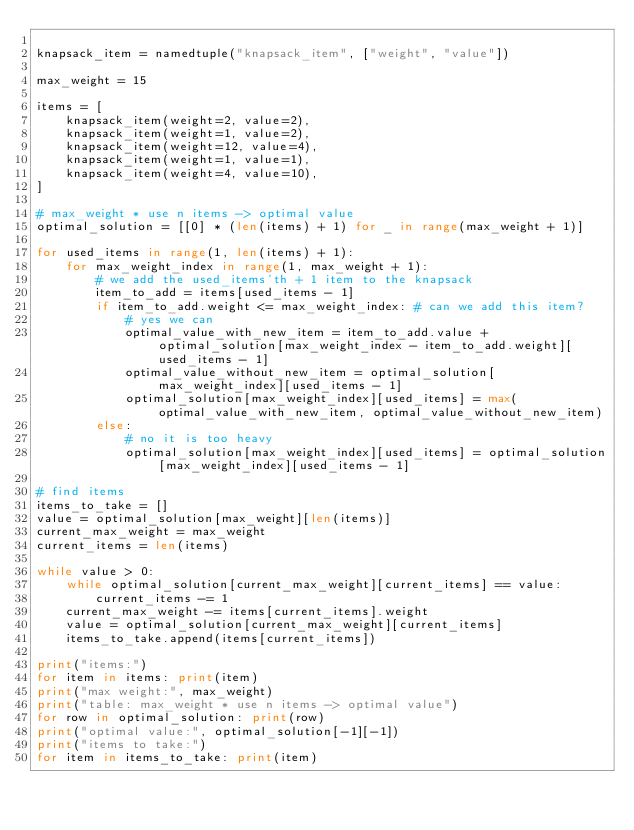Convert code to text. <code><loc_0><loc_0><loc_500><loc_500><_Python_>
knapsack_item = namedtuple("knapsack_item", ["weight", "value"])

max_weight = 15

items = [
    knapsack_item(weight=2, value=2),
    knapsack_item(weight=1, value=2),
    knapsack_item(weight=12, value=4),
    knapsack_item(weight=1, value=1),
    knapsack_item(weight=4, value=10),
]

# max_weight * use n items -> optimal value
optimal_solution = [[0] * (len(items) + 1) for _ in range(max_weight + 1)]

for used_items in range(1, len(items) + 1):
    for max_weight_index in range(1, max_weight + 1):
        # we add the used_items'th + 1 item to the knapsack
        item_to_add = items[used_items - 1]
        if item_to_add.weight <= max_weight_index: # can we add this item?
            # yes we can
            optimal_value_with_new_item = item_to_add.value + optimal_solution[max_weight_index - item_to_add.weight][used_items - 1]
            optimal_value_without_new_item = optimal_solution[max_weight_index][used_items - 1]
            optimal_solution[max_weight_index][used_items] = max(optimal_value_with_new_item, optimal_value_without_new_item)
        else:
            # no it is too heavy
            optimal_solution[max_weight_index][used_items] = optimal_solution[max_weight_index][used_items - 1]

# find items
items_to_take = []
value = optimal_solution[max_weight][len(items)]
current_max_weight = max_weight
current_items = len(items)

while value > 0:
    while optimal_solution[current_max_weight][current_items] == value:
        current_items -= 1
    current_max_weight -= items[current_items].weight
    value = optimal_solution[current_max_weight][current_items]
    items_to_take.append(items[current_items])

print("items:")
for item in items: print(item)
print("max weight:", max_weight)
print("table: max_weight * use n items -> optimal value")
for row in optimal_solution: print(row)
print("optimal value:", optimal_solution[-1][-1])
print("items to take:")
for item in items_to_take: print(item)
</code> 